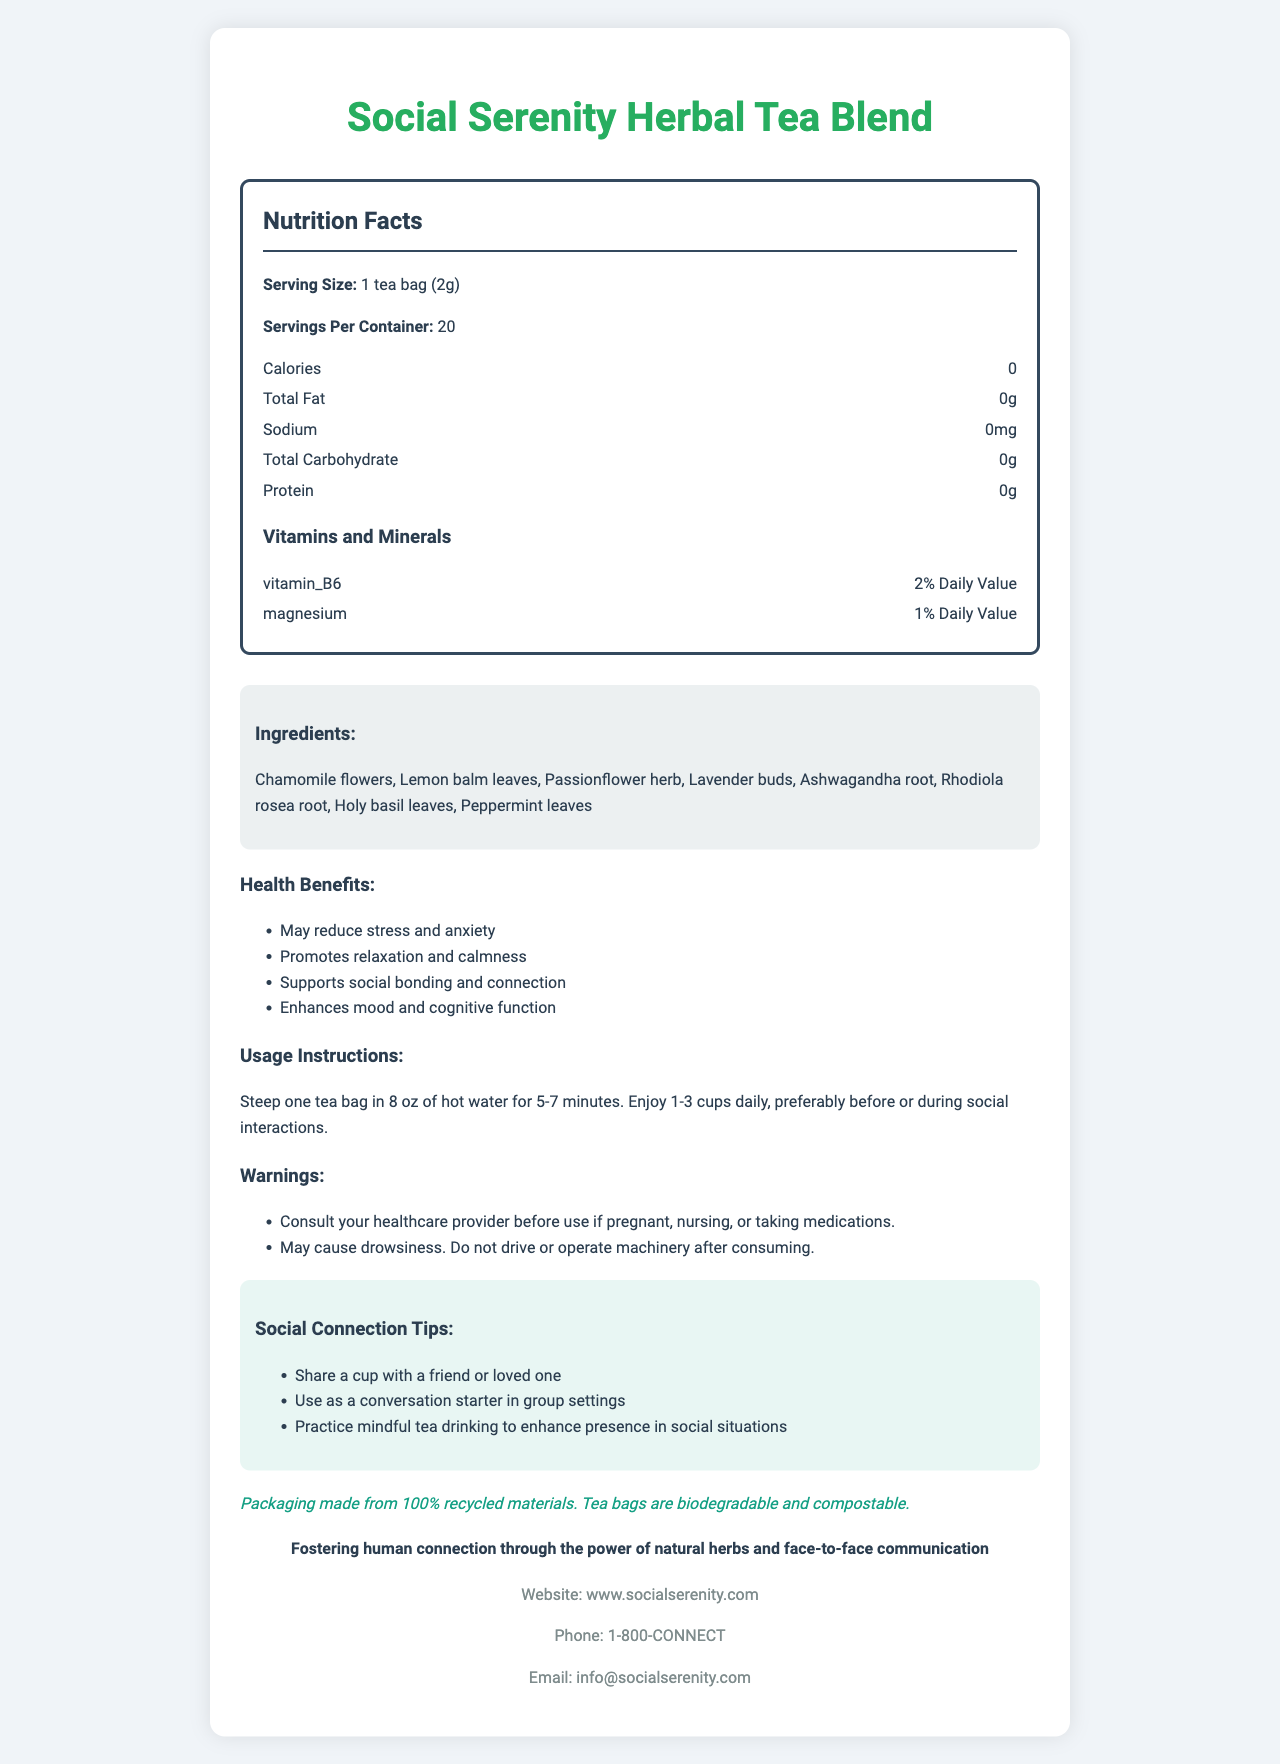what is the serving size for the Social Serenity Herbal Tea Blend? The serving size is listed at the top of the Nutrition Facts section in the document.
Answer: 1 tea bag (2g) how many servings are in each container? The number of servings per container is specified as 20 in the Nutrition Facts section.
Answer: 20 list the main ingredients in this herbal tea. The main ingredients are provided in the Ingredients section of the document.
Answer: Chamomile flowers, Lemon balm leaves, Passionflower herb, Lavender buds, Ashwagandha root, Rhodiola rosea root, Holy basil leaves, Peppermint leaves what percentage of the daily value of vitamin B6 does this tea provide? The percentage for vitamin B6 is mentioned under the "Vitamins and Minerals" subsection in the Nutrition Facts.
Answer: 2% Daily Value how should the Social Serenity Herbal Tea Blend be prepared? The preparation instructions are listed directly under the Usage Instructions.
Answer: Steep one tea bag in 8 oz of hot water for 5-7 minutes. Enjoy 1-3 cups daily, preferably before or during social interactions. which of the following is NOT an ingredient in the Social Serenity Herbal Tea Blend? A. Chamomile flowers B. Lemon balm leaves C. Green tea leaves D. Ashwagandha root Green tea leaves are not listed as an ingredient in the Ingredients section.
Answer: C which of these health benefits is mentioned for the tea? I. May reduce stress and anxiety II. Promotes relaxation and calmness III. Supports immune function IV. Enhances mood and cognitive function The health benefits listed include reducing stress and anxiety, promoting relaxation and calmness, and enhancing mood and cognitive function. Supporting immune function is not listed.
Answer: I, II, IV does this tea contain any calories? The Nutrition Facts indicate that the tea has 0 calories.
Answer: No is the packaging environmentally friendly? The Sustainability Info section mentions that the packaging is made from 100% recycled materials and the tea bags are biodegradable and compostable.
Answer: Yes how should the tea not be used according to the warnings? This warning is directly listed under the Warnings section.
Answer: May cause drowsiness. Do not drive or operate machinery after consuming. what is the company's mission? The company mission is specifically stated in the Company Mission section.
Answer: Fostering human connection through the power of natural herbs and face-to-face communication how does the company suggest using the tea to enhance social connection? These suggestions are listed in the Social Connection Tips section.
Answer: Share a cup with a friend or loved one, use as a conversation starter in group settings, practice mindful tea drinking to enhance presence in social situations what is the email address for customer inquiries? The email address is provided in the Contact Information section.
Answer: info@socialserenity.com summarize the main purpose and information of the document. The main purpose of the document is to inform consumers about the features and benefits of the Social Serenity Herbal Tea Blend, highlighting its role in promoting social interactions and relaxation.
Answer: The document provides detailed information about the Social Serenity Herbal Tea Blend, including its nutrition facts, ingredients, health benefits, usage instructions, warnings, social connection tips, sustainability info, the company’s mission, and contact information. The tea is designed to reduce stress and enhance social connection and is made from natural herbs. how does drinking this tea impact cognitive function? This benefit is explicitly listed under the Health Benefits section.
Answer: Enhances mood and cognitive function does the document mention any restrictions for pregnant or nursing women? The Warnings section advises consulting a healthcare provider before use if pregnant, nursing, or taking medications.
Answer: Yes what flavors does the document describe for this tea blend? The document lists the ingredients but does not describe specific flavors for the tea blend.
Answer: Not enough information 